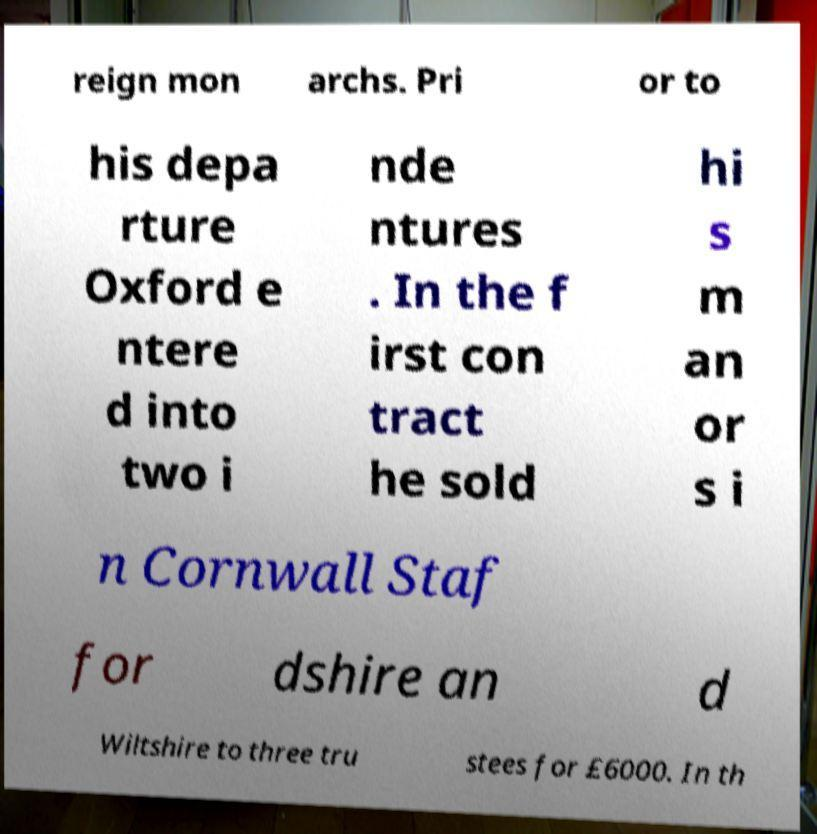I need the written content from this picture converted into text. Can you do that? reign mon archs. Pri or to his depa rture Oxford e ntere d into two i nde ntures . In the f irst con tract he sold hi s m an or s i n Cornwall Staf for dshire an d Wiltshire to three tru stees for £6000. In th 